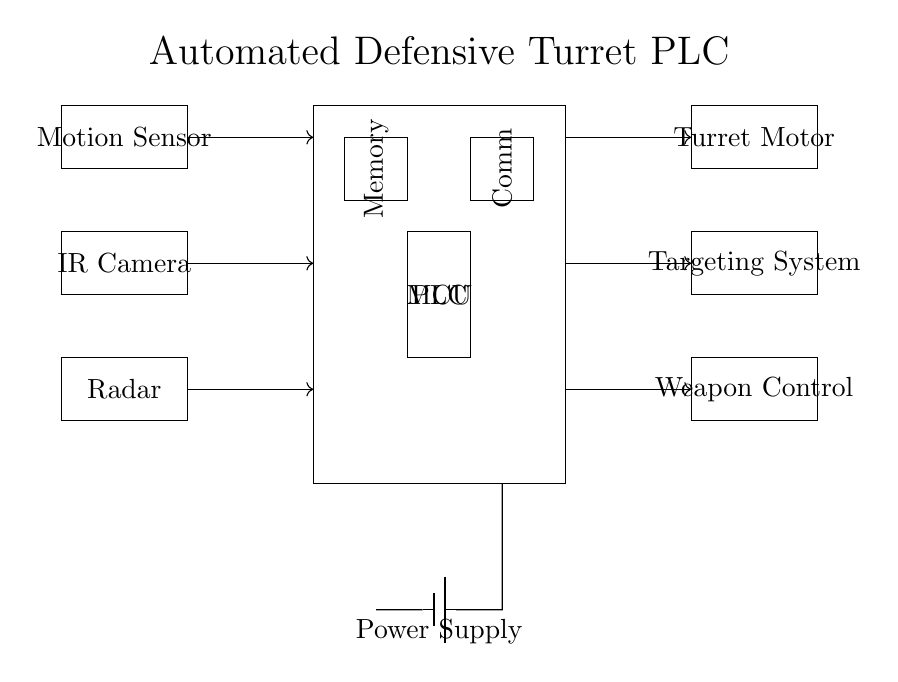What is the main component of this circuit? The main component is the PLC, which stands for Programmable Logic Controller. It acts as the central controlling unit in this automated turret system.
Answer: PLC How many input devices are present in the circuit? There are three input devices: a Motion Sensor, an IR Camera, and a Radar. Each plays a role in detecting threats or targets for the turret system.
Answer: 3 Which component processes communication in the circuit? The communication in this circuit is handled by the Comm module, which facilitates communication between the PLC and other systems or devices.
Answer: Comm What type of power supply is used in this circuit? The power supply is represented by a battery, which provides the necessary voltage to operate the PLC and its connected components.
Answer: Battery How many output devices does the PLC control? The PLC controls three output devices: a Turret Motor, a Targeting System, and a Weapon Control unit. These components are activated based on the input received from sensors.
Answer: 3 Explain the relationship between the Motion Sensor and the PLC. The Motion Sensor sends signals to the PLC indicating detected movements or potential threats. The PLC processes this data to make decisions regarding turret actions, such as tracking or targeting.
Answer: Input signal What is the function of the Memory component in the circuit? The Memory component stores programmed instructions and data that the PLC uses to make decisions and control the turret system based on inputs received from the sensors.
Answer: Storage 